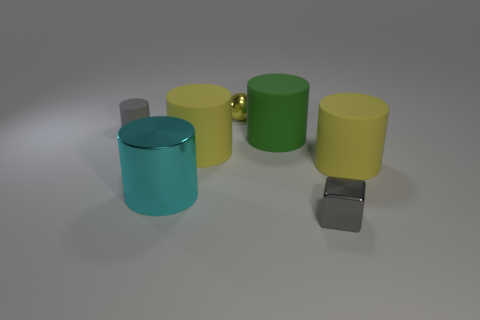Subtract all gray cylinders. How many cylinders are left? 4 Add 1 gray metal cylinders. How many objects exist? 8 Subtract all green cylinders. How many cylinders are left? 4 Subtract all red blocks. How many green cylinders are left? 1 Subtract all gray matte things. Subtract all gray cubes. How many objects are left? 5 Add 2 small things. How many small things are left? 5 Add 5 large shiny things. How many large shiny things exist? 6 Subtract 0 cyan balls. How many objects are left? 7 Subtract all blocks. How many objects are left? 6 Subtract 1 balls. How many balls are left? 0 